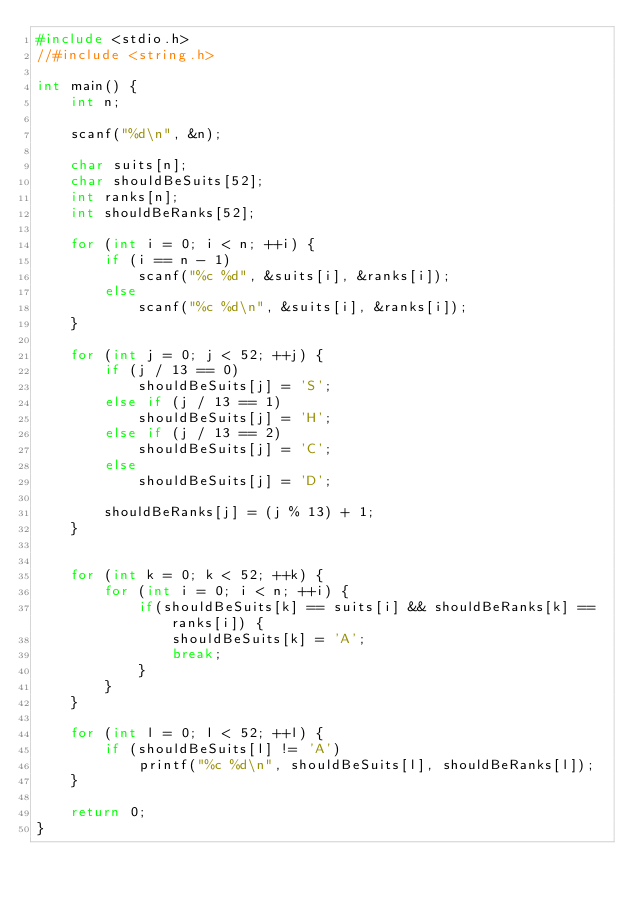<code> <loc_0><loc_0><loc_500><loc_500><_C_>#include <stdio.h>
//#include <string.h>

int main() {
    int n;

    scanf("%d\n", &n);

    char suits[n];
    char shouldBeSuits[52];
    int ranks[n];
    int shouldBeRanks[52];

    for (int i = 0; i < n; ++i) {
        if (i == n - 1)
            scanf("%c %d", &suits[i], &ranks[i]);
        else
            scanf("%c %d\n", &suits[i], &ranks[i]);
    }

    for (int j = 0; j < 52; ++j) {
        if (j / 13 == 0)
            shouldBeSuits[j] = 'S';
        else if (j / 13 == 1)
            shouldBeSuits[j] = 'H';
        else if (j / 13 == 2)
            shouldBeSuits[j] = 'C';
        else
            shouldBeSuits[j] = 'D';

        shouldBeRanks[j] = (j % 13) + 1;
    }


    for (int k = 0; k < 52; ++k) {
        for (int i = 0; i < n; ++i) {
            if(shouldBeSuits[k] == suits[i] && shouldBeRanks[k] == ranks[i]) {
                shouldBeSuits[k] = 'A';
                break;
            }
        }
    }

    for (int l = 0; l < 52; ++l) {
        if (shouldBeSuits[l] != 'A')
            printf("%c %d\n", shouldBeSuits[l], shouldBeRanks[l]);
    }

    return 0;
}
</code> 